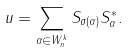<formula> <loc_0><loc_0><loc_500><loc_500>u = \sum _ { \alpha \in W _ { n } ^ { k } } S _ { \sigma ( \alpha ) } S _ { \alpha } ^ { * } .</formula> 